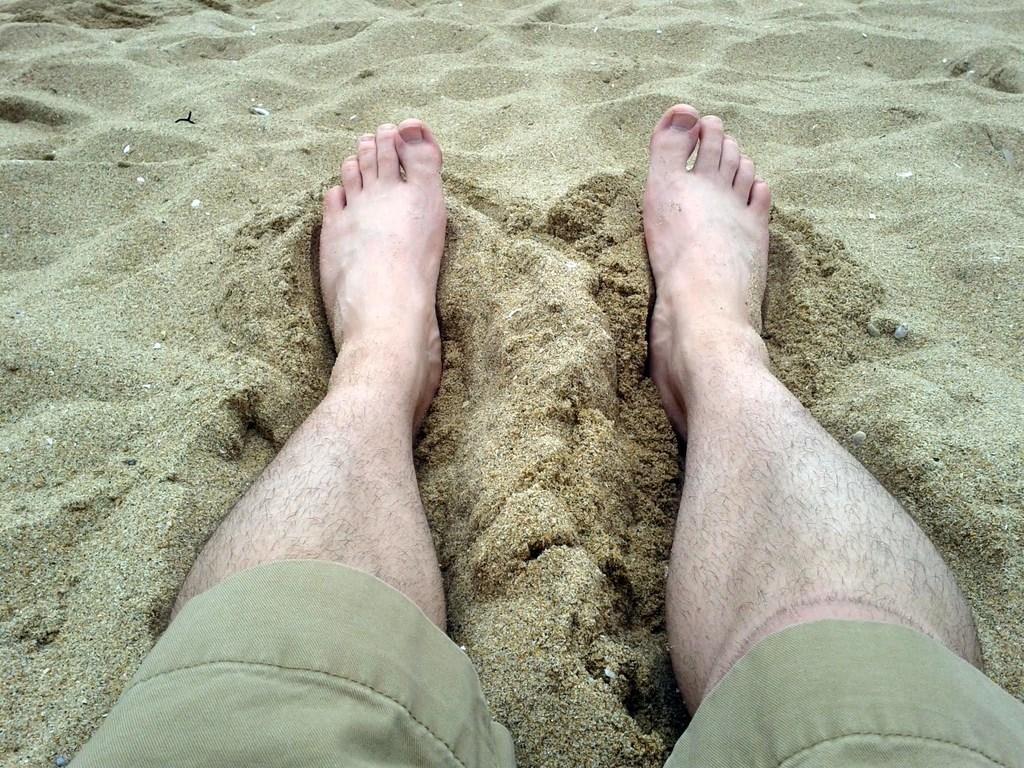Can you describe this image briefly? In this image there are two legs in the sand. 